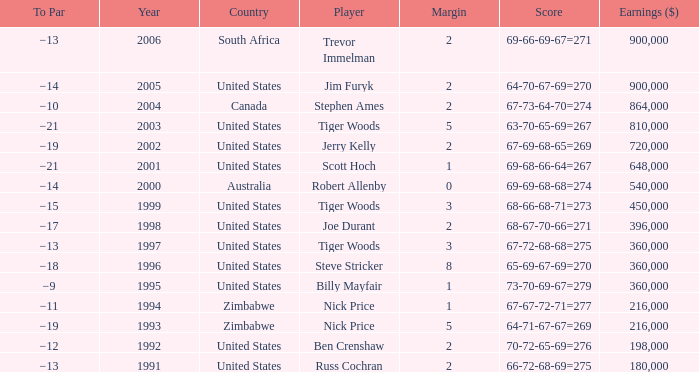What is canada's margin? 2.0. 